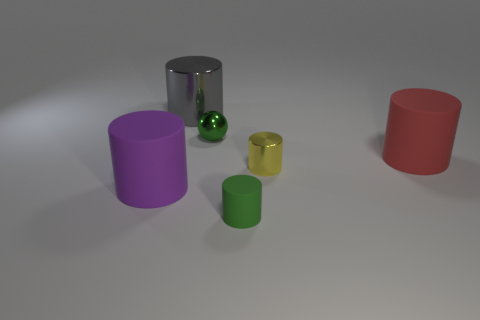Subtract all green cylinders. How many cylinders are left? 4 Subtract all cyan cylinders. Subtract all blue cubes. How many cylinders are left? 5 Add 2 big metal things. How many objects exist? 8 Subtract all cylinders. How many objects are left? 1 Subtract all red objects. Subtract all large gray shiny things. How many objects are left? 4 Add 4 big purple cylinders. How many big purple cylinders are left? 5 Add 4 small green cylinders. How many small green cylinders exist? 5 Subtract 1 purple cylinders. How many objects are left? 5 